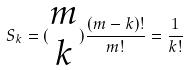<formula> <loc_0><loc_0><loc_500><loc_500>S _ { k } = ( \begin{matrix} m \\ k \end{matrix} ) \frac { ( m - k ) ! } { m ! } = \frac { 1 } { k ! }</formula> 